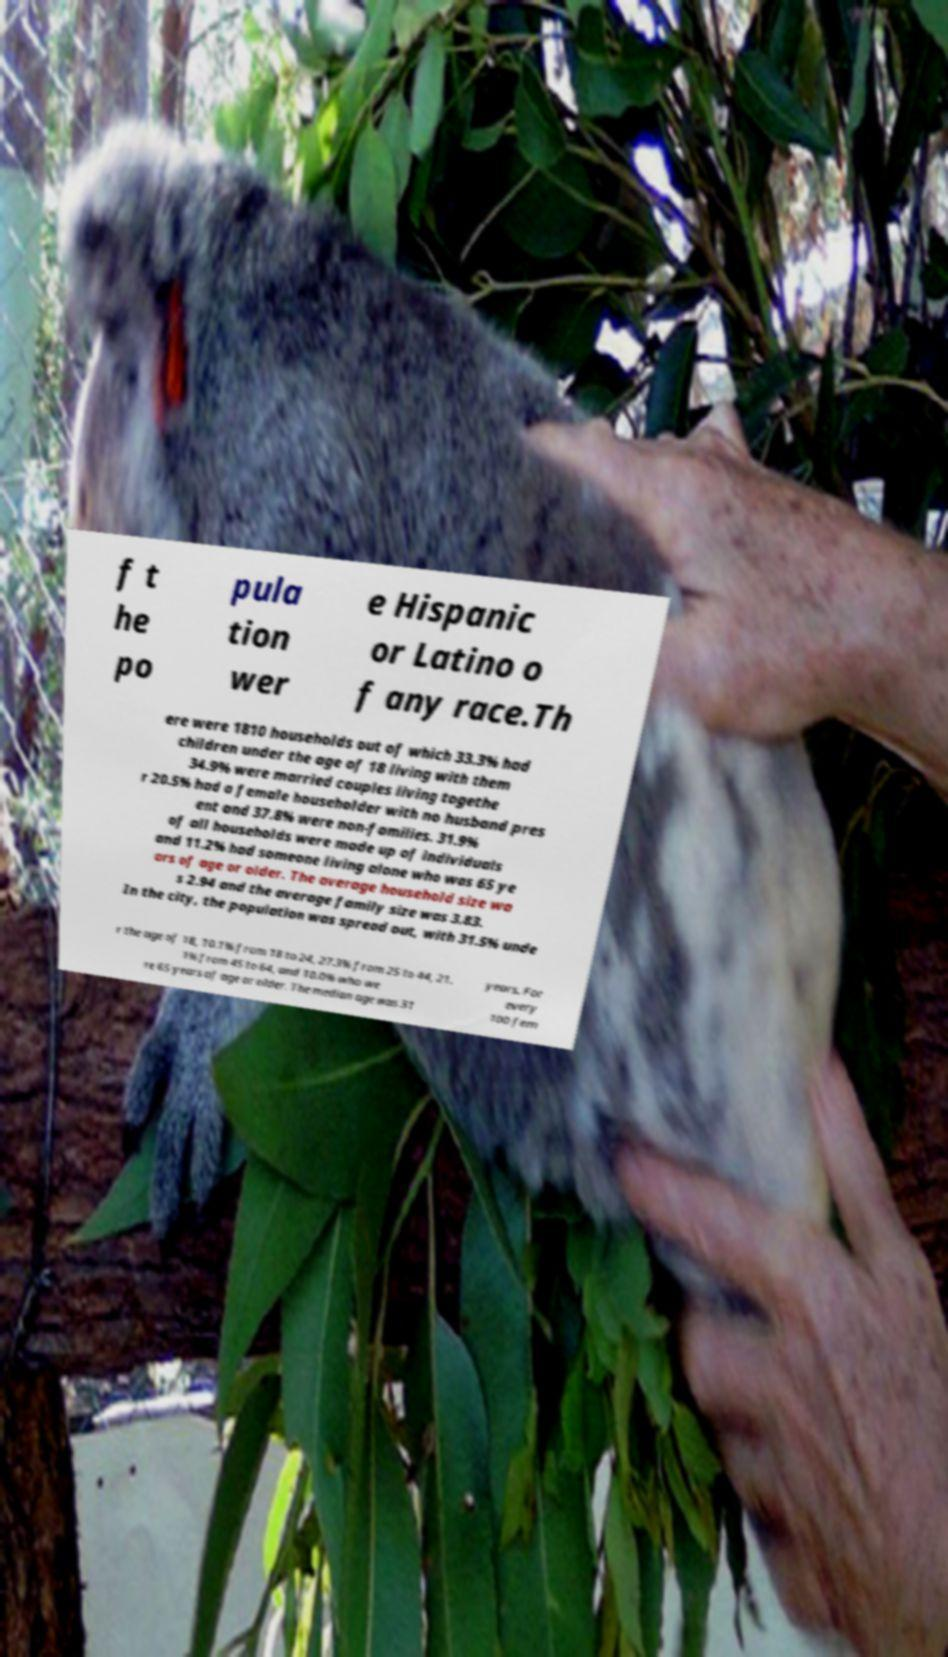Could you assist in decoding the text presented in this image and type it out clearly? f t he po pula tion wer e Hispanic or Latino o f any race.Th ere were 1810 households out of which 33.3% had children under the age of 18 living with them 34.9% were married couples living togethe r 20.5% had a female householder with no husband pres ent and 37.8% were non-families. 31.9% of all households were made up of individuals and 11.2% had someone living alone who was 65 ye ars of age or older. The average household size wa s 2.94 and the average family size was 3.83. In the city, the population was spread out, with 31.5% unde r the age of 18, 10.1% from 18 to 24, 27.3% from 25 to 44, 21. 1% from 45 to 64, and 10.0% who we re 65 years of age or older. The median age was 31 years. For every 100 fem 